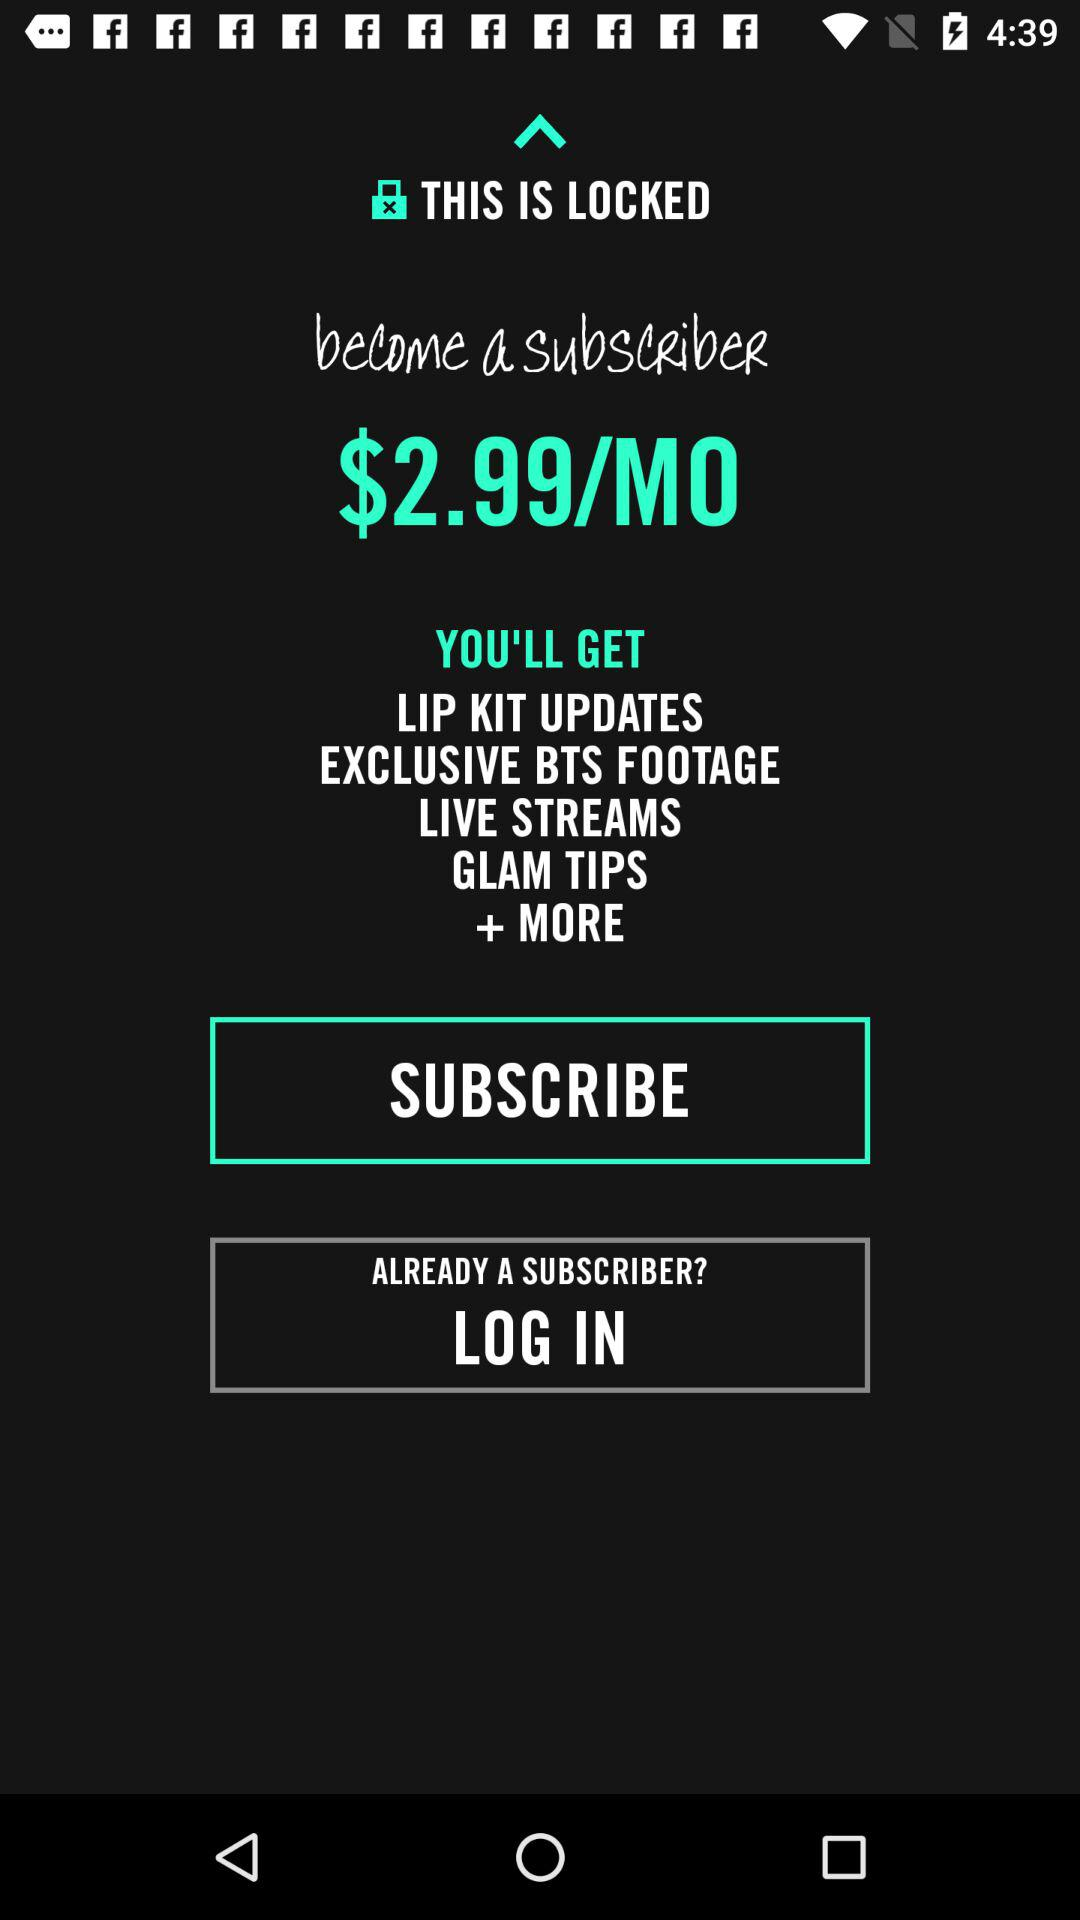What are the benefits of subscribing? The benefits of subscribing are "LIP KIT UPDATES", "EXCLUSIVE BTS FOOTAGE", "LIVE STREAMS", "GLAM TIPS" and "+ MORE". 